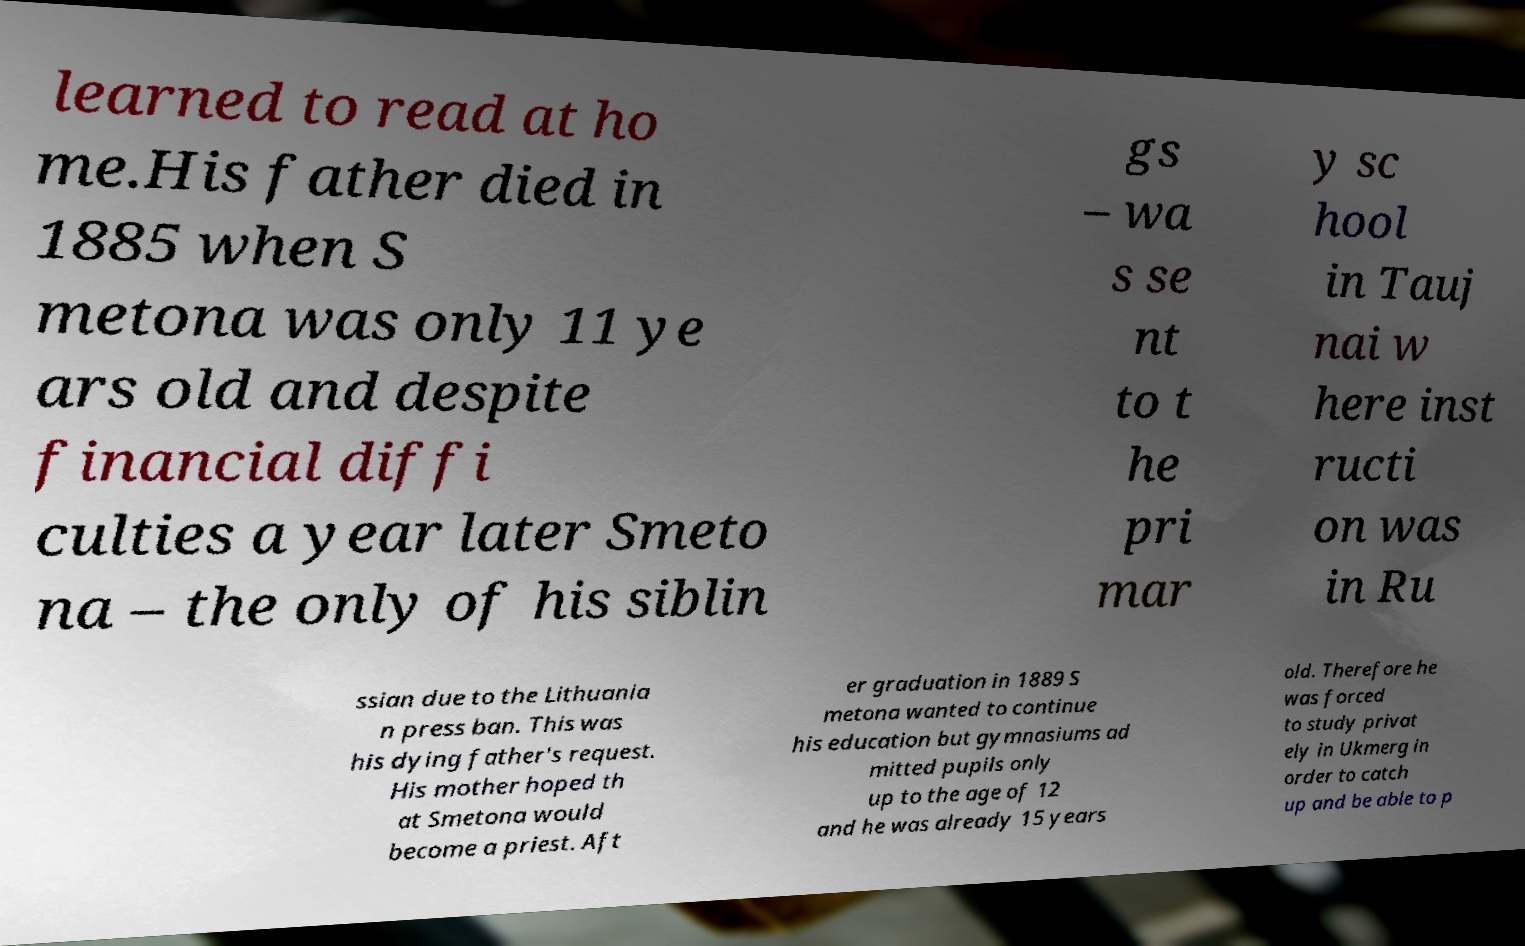What messages or text are displayed in this image? I need them in a readable, typed format. learned to read at ho me.His father died in 1885 when S metona was only 11 ye ars old and despite financial diffi culties a year later Smeto na – the only of his siblin gs – wa s se nt to t he pri mar y sc hool in Tauj nai w here inst ructi on was in Ru ssian due to the Lithuania n press ban. This was his dying father's request. His mother hoped th at Smetona would become a priest. Aft er graduation in 1889 S metona wanted to continue his education but gymnasiums ad mitted pupils only up to the age of 12 and he was already 15 years old. Therefore he was forced to study privat ely in Ukmerg in order to catch up and be able to p 